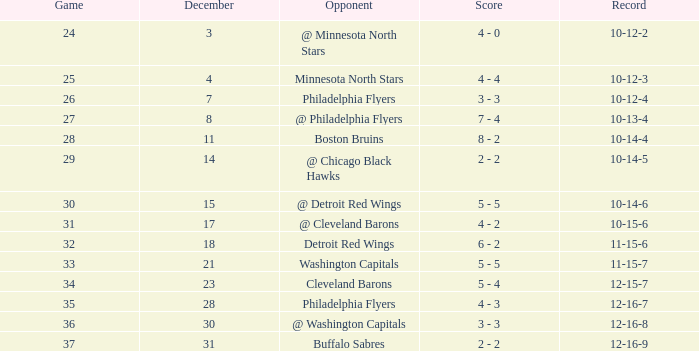Who is the adversary when the game is "37"? Buffalo Sabres. 